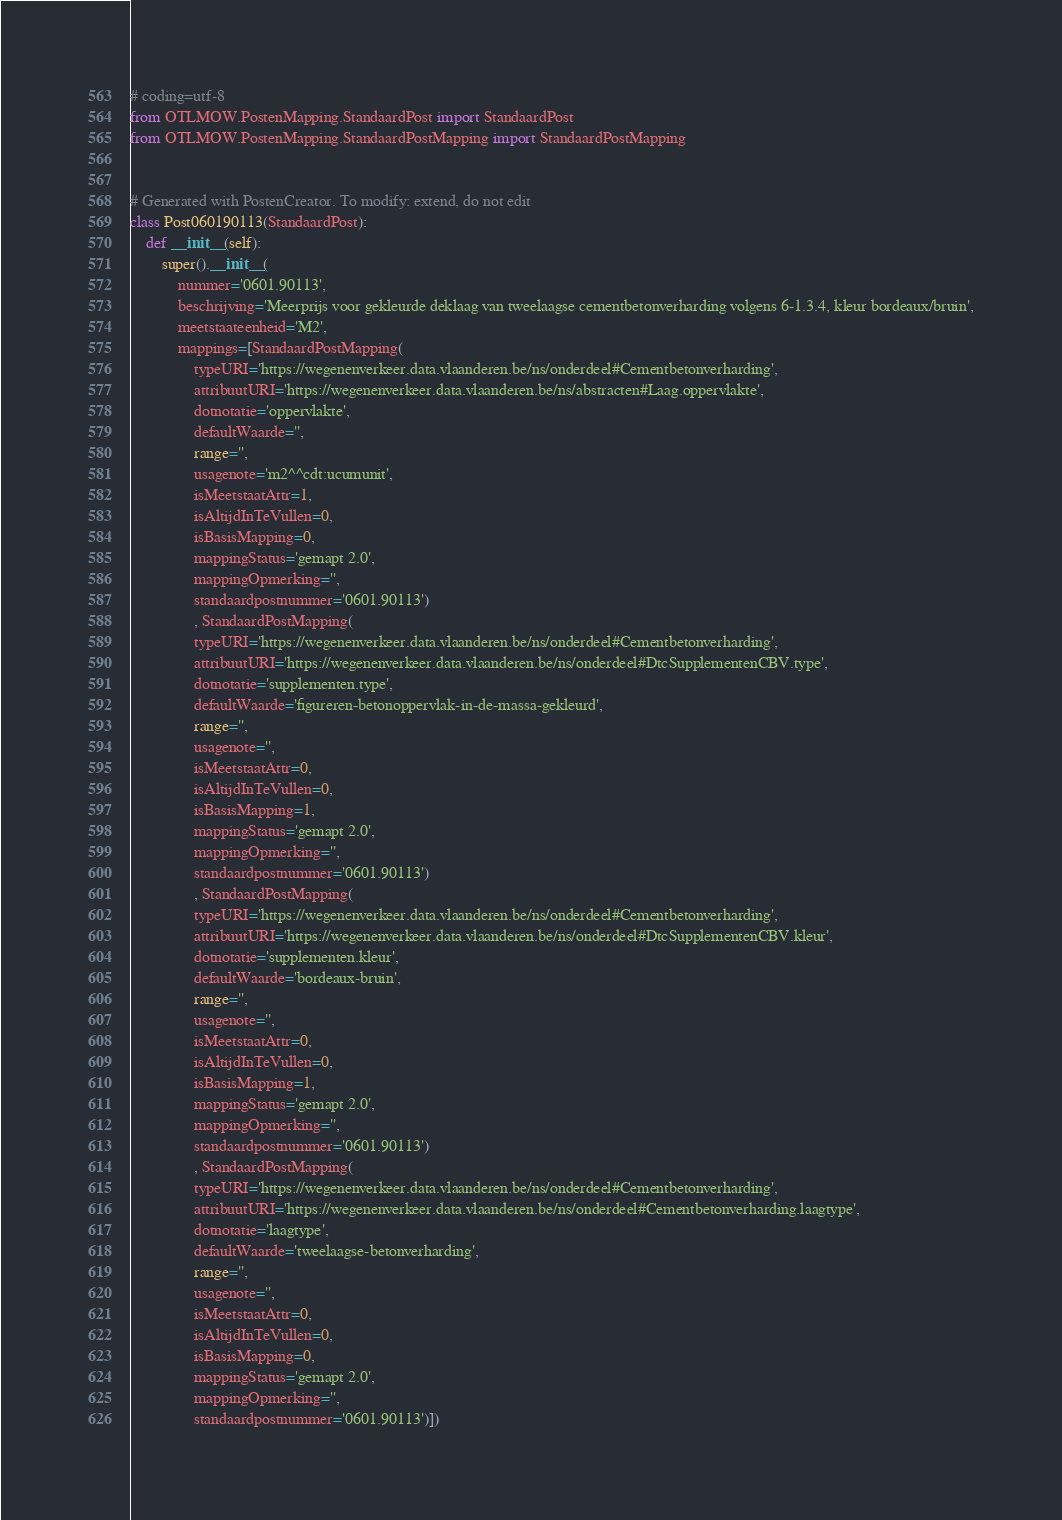Convert code to text. <code><loc_0><loc_0><loc_500><loc_500><_Python_># coding=utf-8
from OTLMOW.PostenMapping.StandaardPost import StandaardPost
from OTLMOW.PostenMapping.StandaardPostMapping import StandaardPostMapping


# Generated with PostenCreator. To modify: extend, do not edit
class Post060190113(StandaardPost):
    def __init__(self):
        super().__init__(
            nummer='0601.90113',
            beschrijving='Meerprijs voor gekleurde deklaag van tweelaagse cementbetonverharding volgens 6-1.3.4, kleur bordeaux/bruin',
            meetstaateenheid='M2',
            mappings=[StandaardPostMapping(
                typeURI='https://wegenenverkeer.data.vlaanderen.be/ns/onderdeel#Cementbetonverharding',
                attribuutURI='https://wegenenverkeer.data.vlaanderen.be/ns/abstracten#Laag.oppervlakte',
                dotnotatie='oppervlakte',
                defaultWaarde='',
                range='',
                usagenote='m2^^cdt:ucumunit',
                isMeetstaatAttr=1,
                isAltijdInTeVullen=0,
                isBasisMapping=0,
                mappingStatus='gemapt 2.0',
                mappingOpmerking='',
                standaardpostnummer='0601.90113')
                , StandaardPostMapping(
                typeURI='https://wegenenverkeer.data.vlaanderen.be/ns/onderdeel#Cementbetonverharding',
                attribuutURI='https://wegenenverkeer.data.vlaanderen.be/ns/onderdeel#DtcSupplementenCBV.type',
                dotnotatie='supplementen.type',
                defaultWaarde='figureren-betonoppervlak-in-de-massa-gekleurd',
                range='',
                usagenote='',
                isMeetstaatAttr=0,
                isAltijdInTeVullen=0,
                isBasisMapping=1,
                mappingStatus='gemapt 2.0',
                mappingOpmerking='',
                standaardpostnummer='0601.90113')
                , StandaardPostMapping(
                typeURI='https://wegenenverkeer.data.vlaanderen.be/ns/onderdeel#Cementbetonverharding',
                attribuutURI='https://wegenenverkeer.data.vlaanderen.be/ns/onderdeel#DtcSupplementenCBV.kleur',
                dotnotatie='supplementen.kleur',
                defaultWaarde='bordeaux-bruin',
                range='',
                usagenote='',
                isMeetstaatAttr=0,
                isAltijdInTeVullen=0,
                isBasisMapping=1,
                mappingStatus='gemapt 2.0',
                mappingOpmerking='',
                standaardpostnummer='0601.90113')
                , StandaardPostMapping(
                typeURI='https://wegenenverkeer.data.vlaanderen.be/ns/onderdeel#Cementbetonverharding',
                attribuutURI='https://wegenenverkeer.data.vlaanderen.be/ns/onderdeel#Cementbetonverharding.laagtype',
                dotnotatie='laagtype',
                defaultWaarde='tweelaagse-betonverharding',
                range='',
                usagenote='',
                isMeetstaatAttr=0,
                isAltijdInTeVullen=0,
                isBasisMapping=0,
                mappingStatus='gemapt 2.0',
                mappingOpmerking='',
                standaardpostnummer='0601.90113')])
</code> 